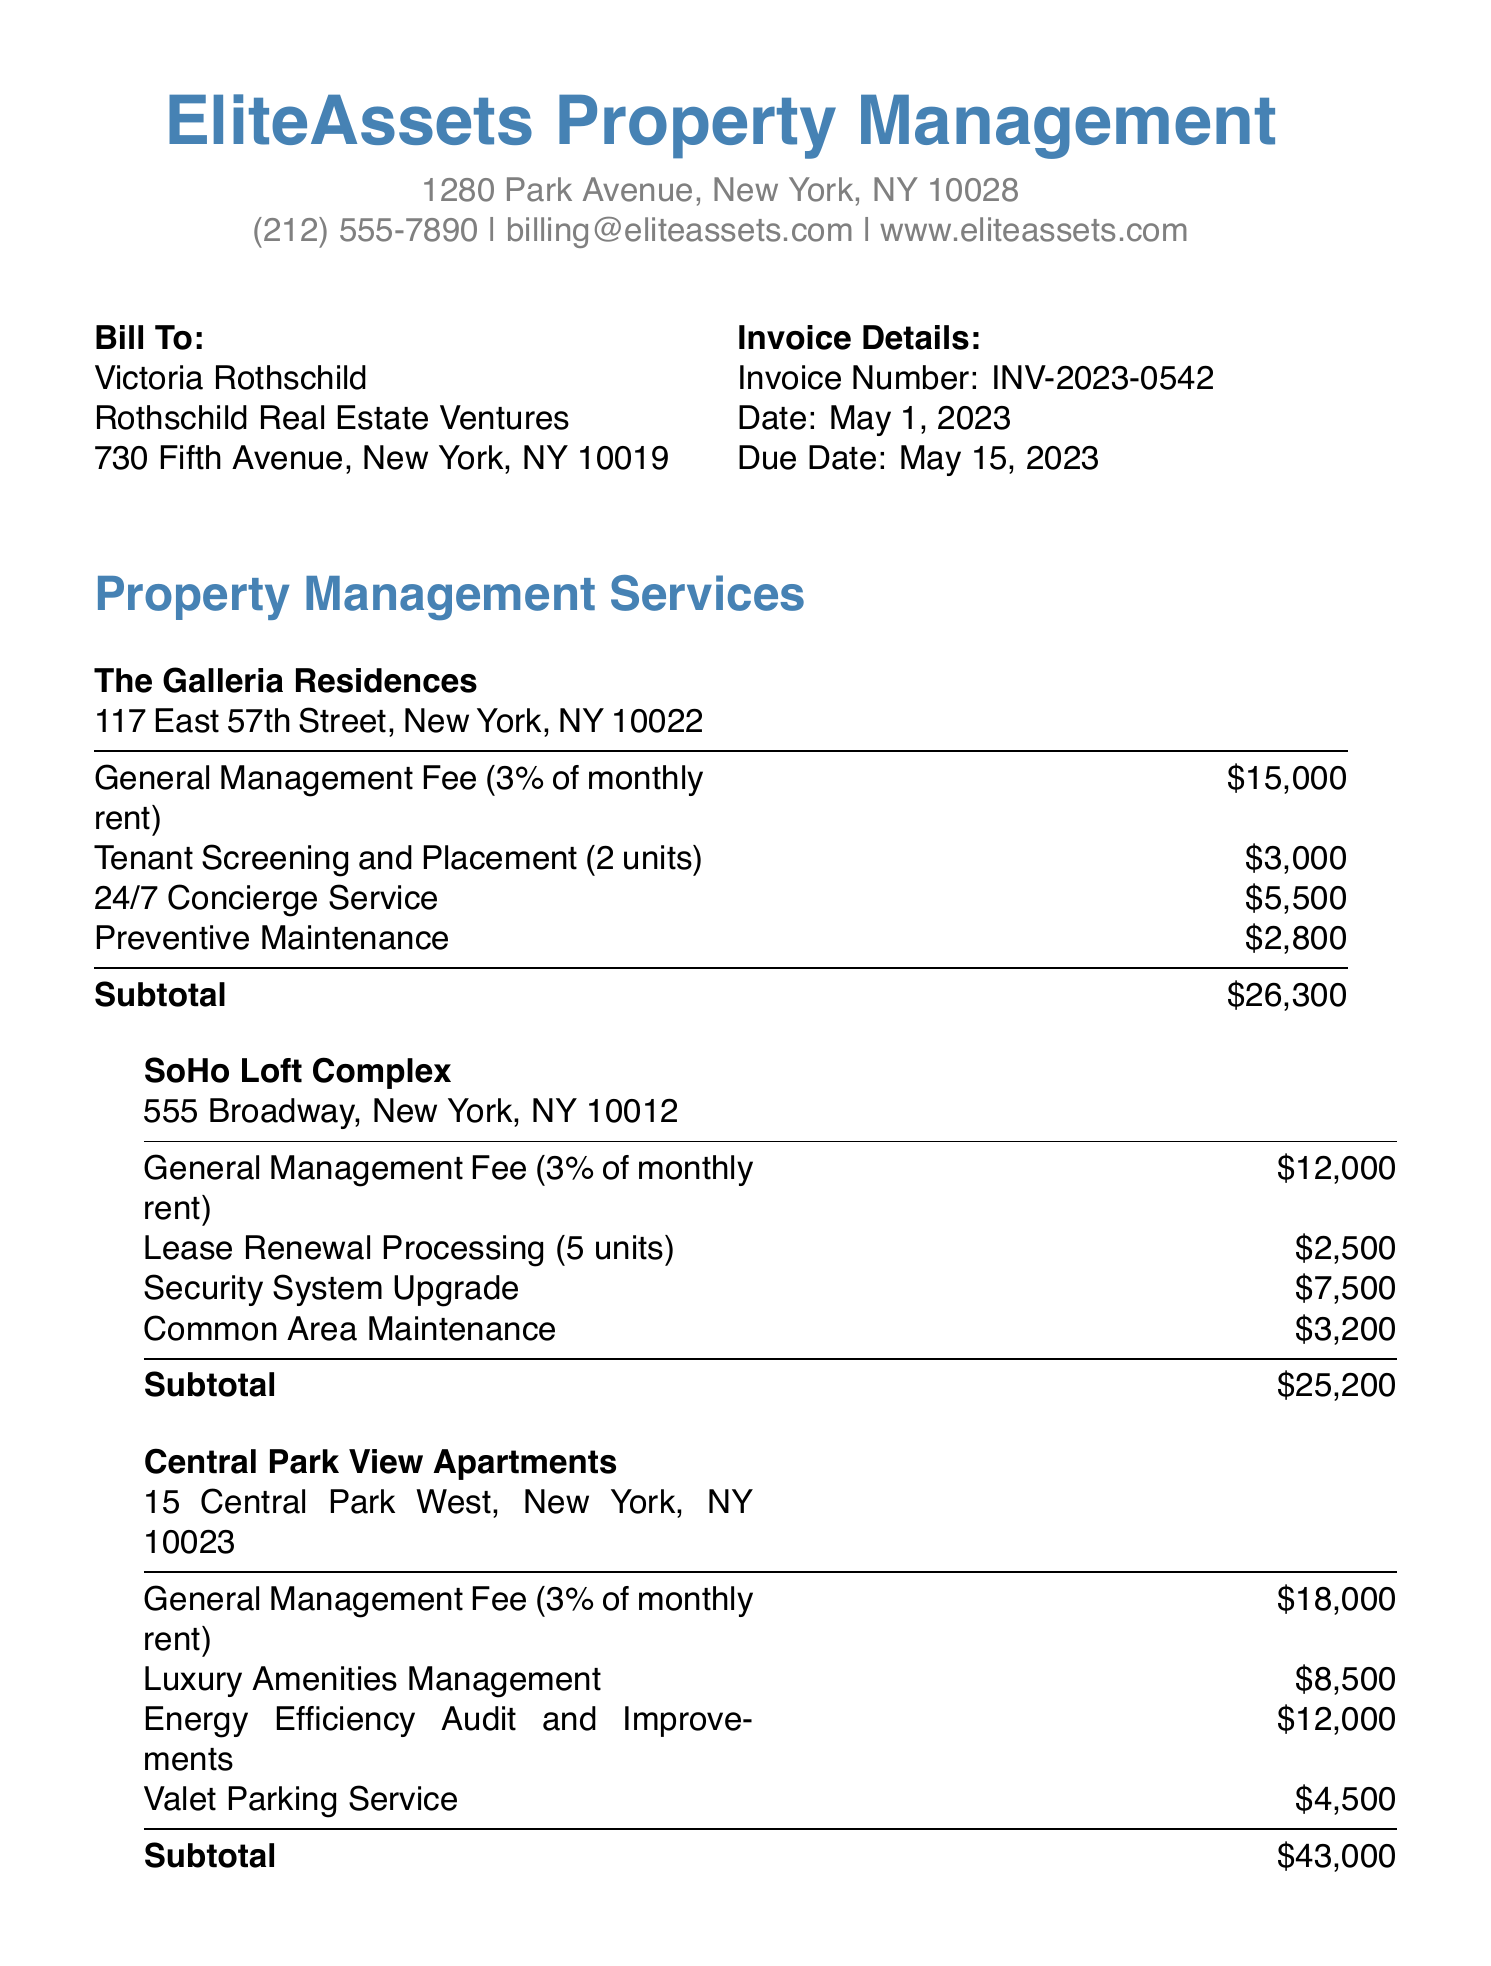What is the invoice number? The invoice number is specified in the invoice details section, which is INV-2023-0542.
Answer: INV-2023-0542 What is the due date of the invoice? The due date is stated in the invoice details section as May 15, 2023.
Answer: May 15, 2023 What is the total due amount? The total due amount is indicated at the end of the invoice as $114,700.
Answer: $114,700 How much is charged for 24/7 Concierge Service at The Galleria Residences? This amount is listed in the services section for The Galleria Residences, which is $5,500.
Answer: $5,500 What service is provided at a cost of $8,500 in Central Park View Apartments? The service for this amount is Luxury Amenities Management, as detailed in the properties section for Central Park View Apartments.
Answer: Luxury Amenities Management What percentage is the General Management Fee based on? The General Management Fee is based on 3% of the monthly rent, according to the service descriptions.
Answer: 3% How many units underwent Tenant Screening and Placement at The Galleria Residences? The document specifies that 2 units were screened and placed under this service.
Answer: 2 units What is the method to make an online payment? The invoice provides instructions to visit the website www.eliteassets.com/pay and use Client ID RREV2023 for online payments.
Answer: www.eliteassets.com/pay What is stated about late payments in the terms and conditions? The terms state that late payments are subject to a 1.5% monthly interest charge.
Answer: 1.5% monthly interest charge 